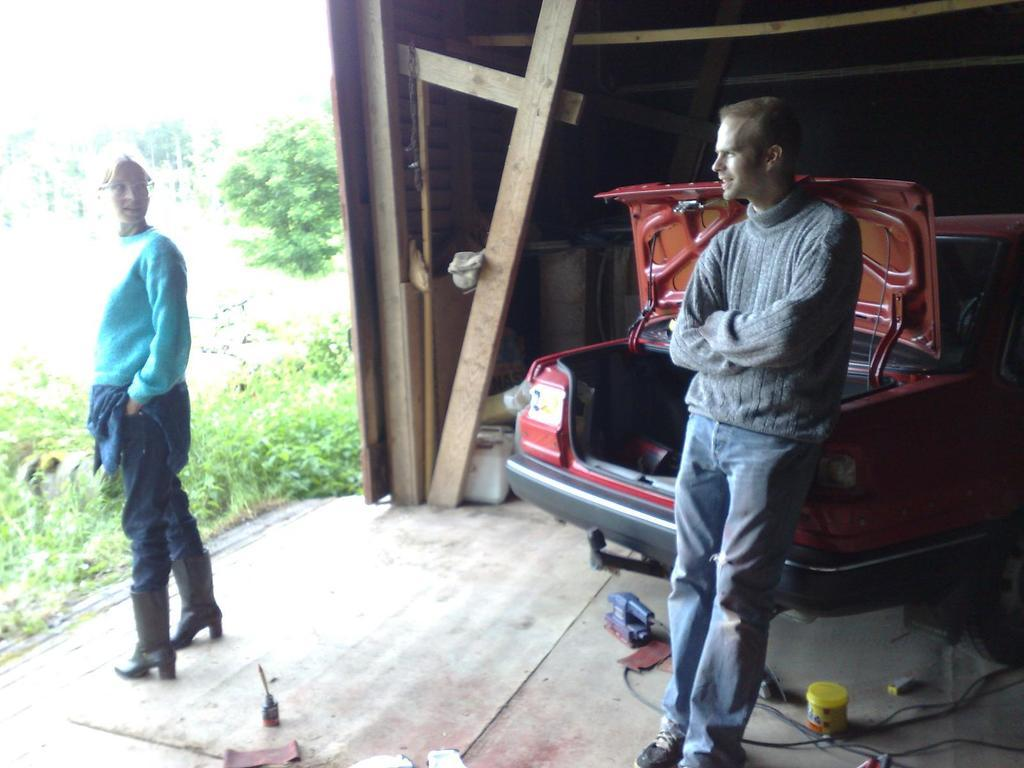How many people are present in the image? There are two persons standing in the image. What else can be seen in the image besides the people? There is a vehicle, wooden objects, trees, and plants in the image. Where is the zebra located in the image? There is no zebra present in the image. What type of spot can be seen on the wooden objects in the image? There are no spots mentioned or visible on the wooden objects in the image. 